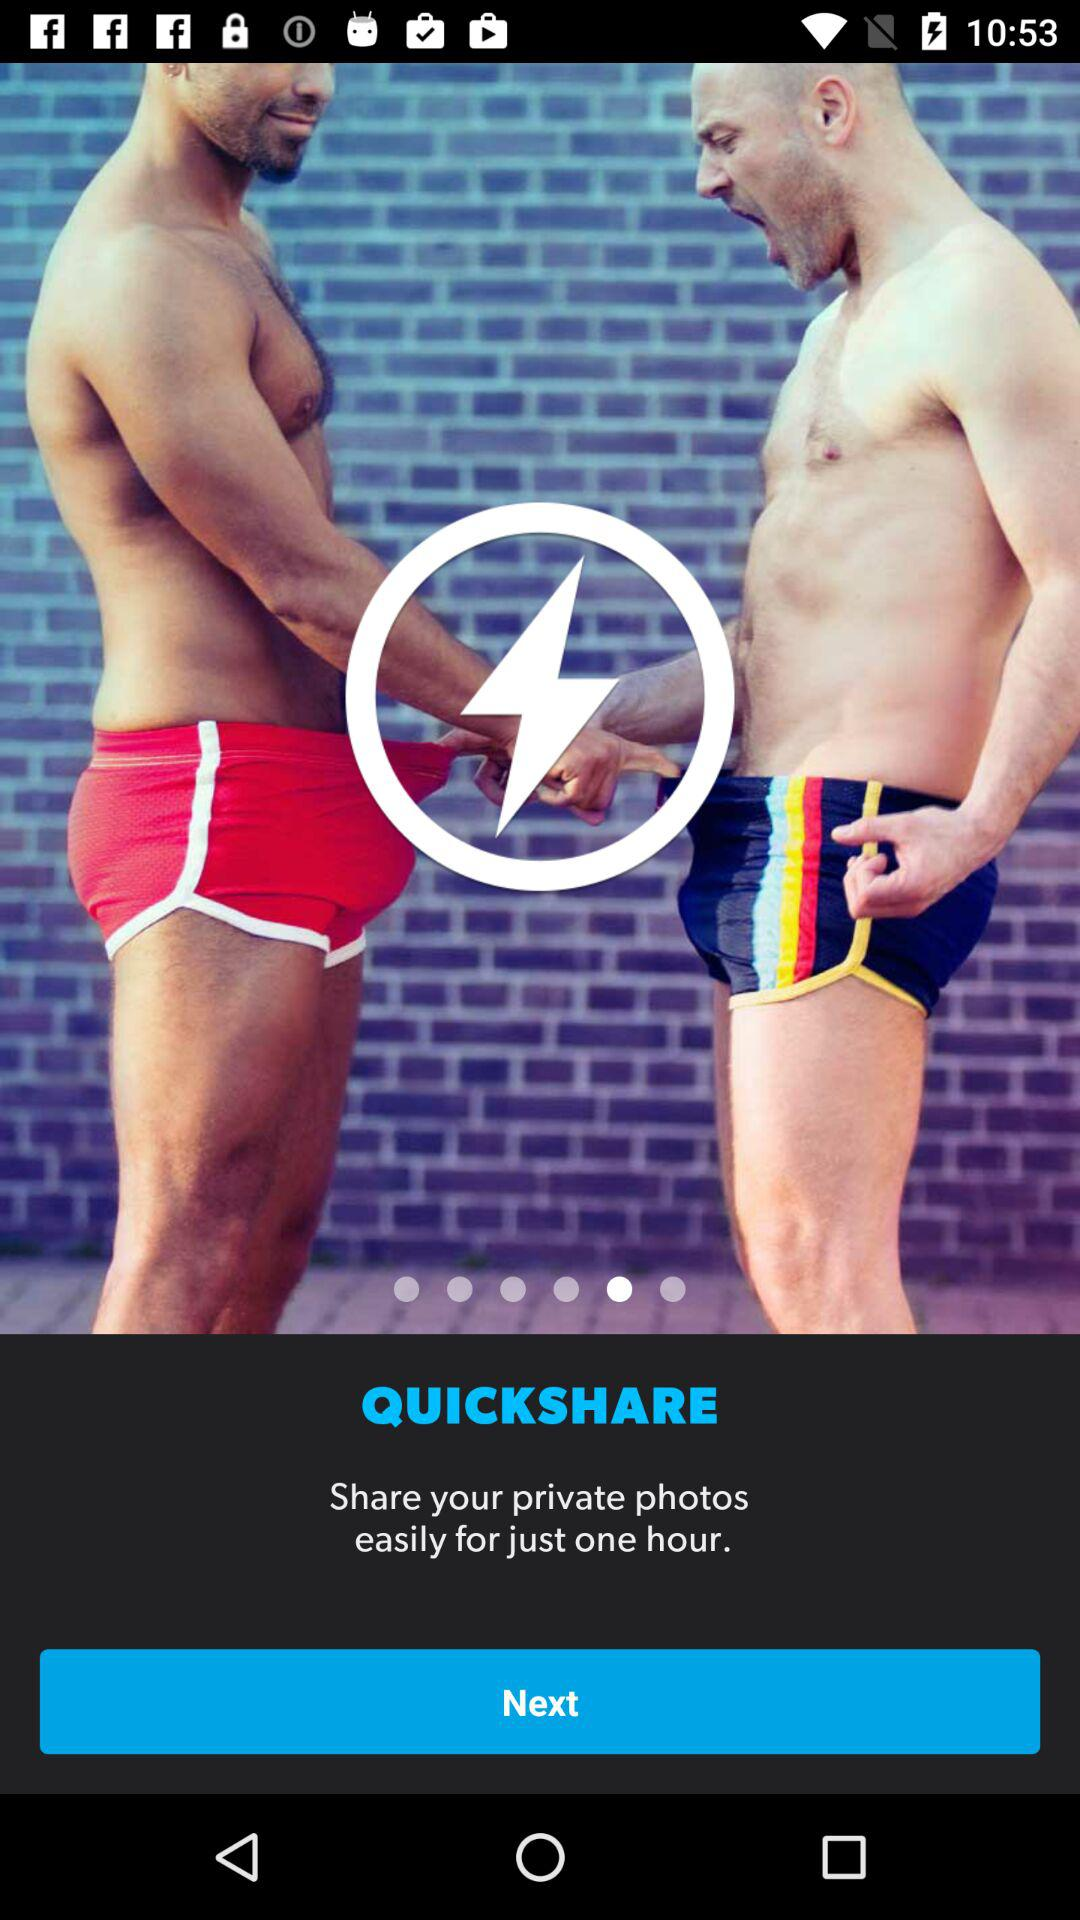How many photos can be shared for just one hour?
When the provided information is insufficient, respond with <no answer>. <no answer> 